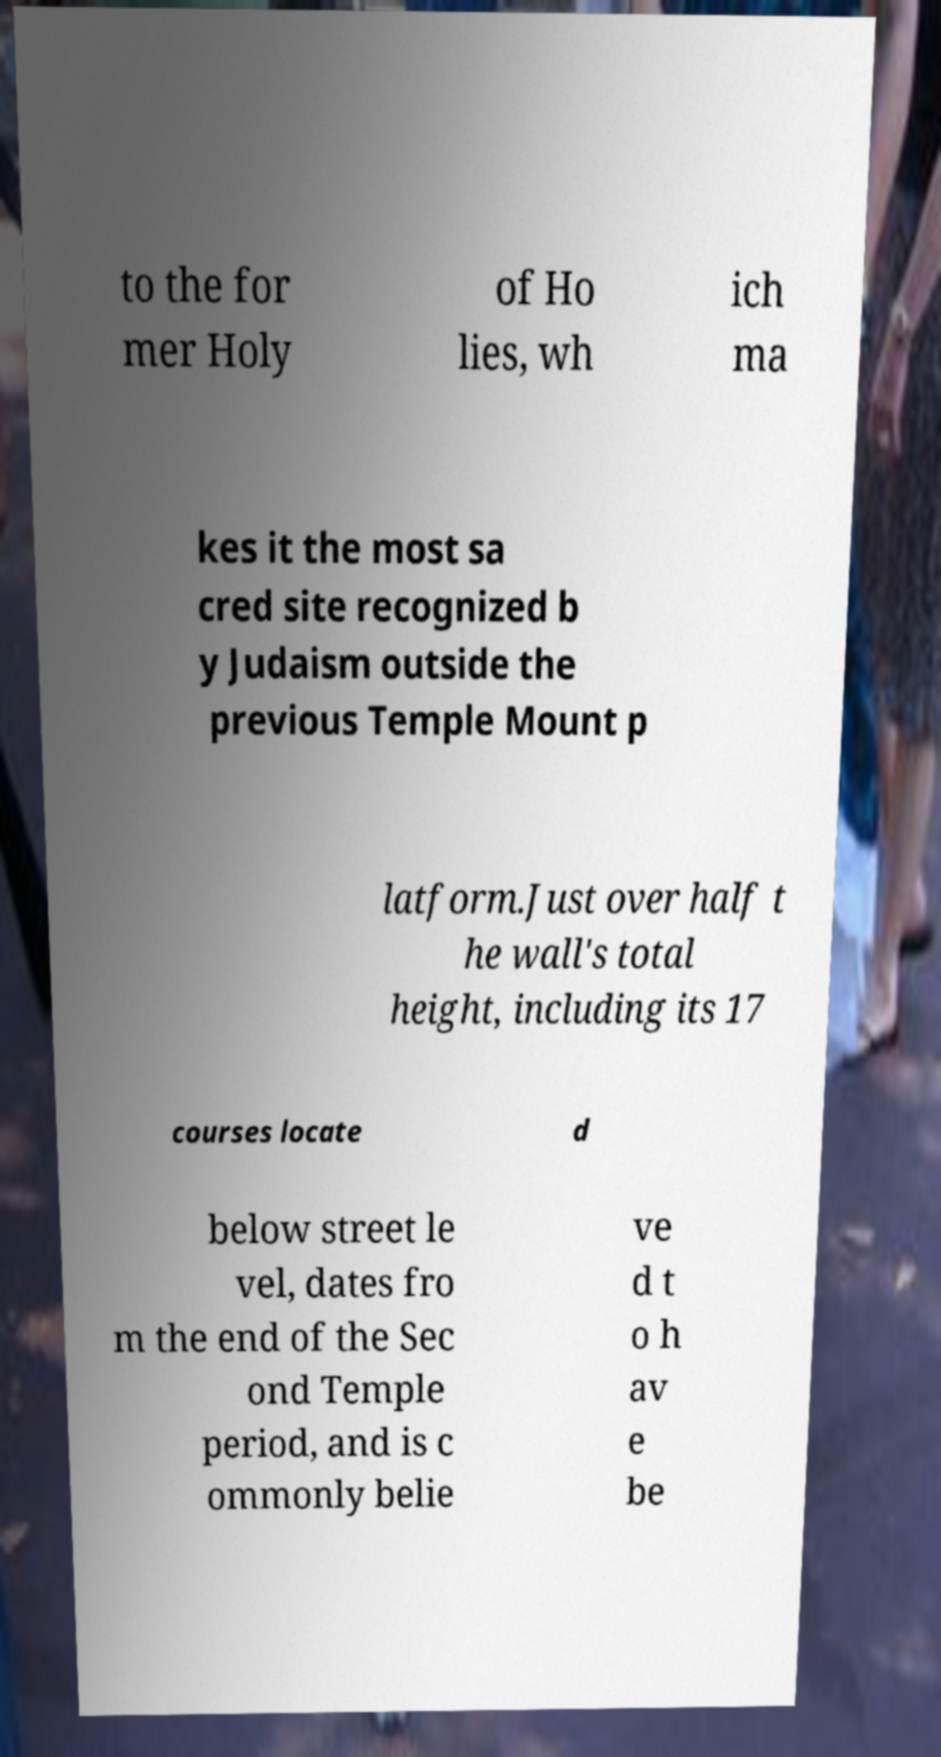Please read and relay the text visible in this image. What does it say? to the for mer Holy of Ho lies, wh ich ma kes it the most sa cred site recognized b y Judaism outside the previous Temple Mount p latform.Just over half t he wall's total height, including its 17 courses locate d below street le vel, dates fro m the end of the Sec ond Temple period, and is c ommonly belie ve d t o h av e be 